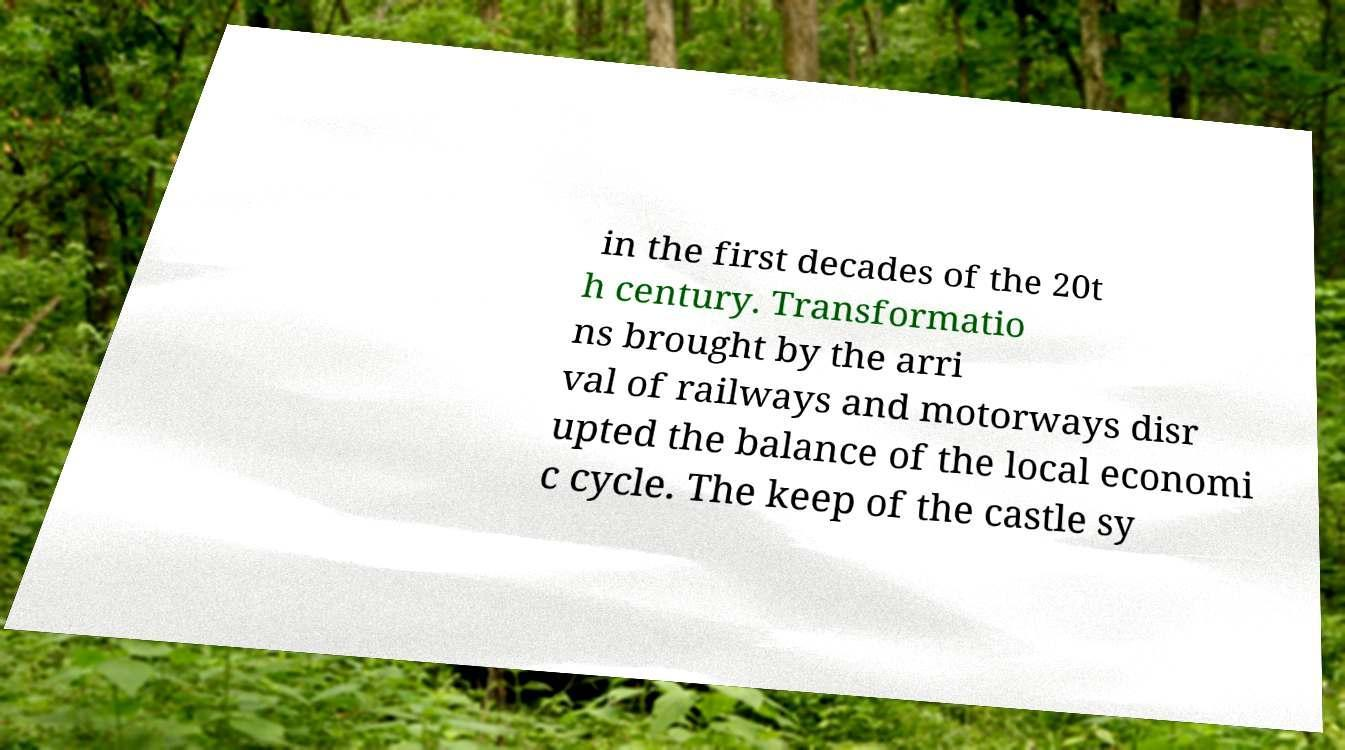Please identify and transcribe the text found in this image. in the first decades of the 20t h century. Transformatio ns brought by the arri val of railways and motorways disr upted the balance of the local economi c cycle. The keep of the castle sy 